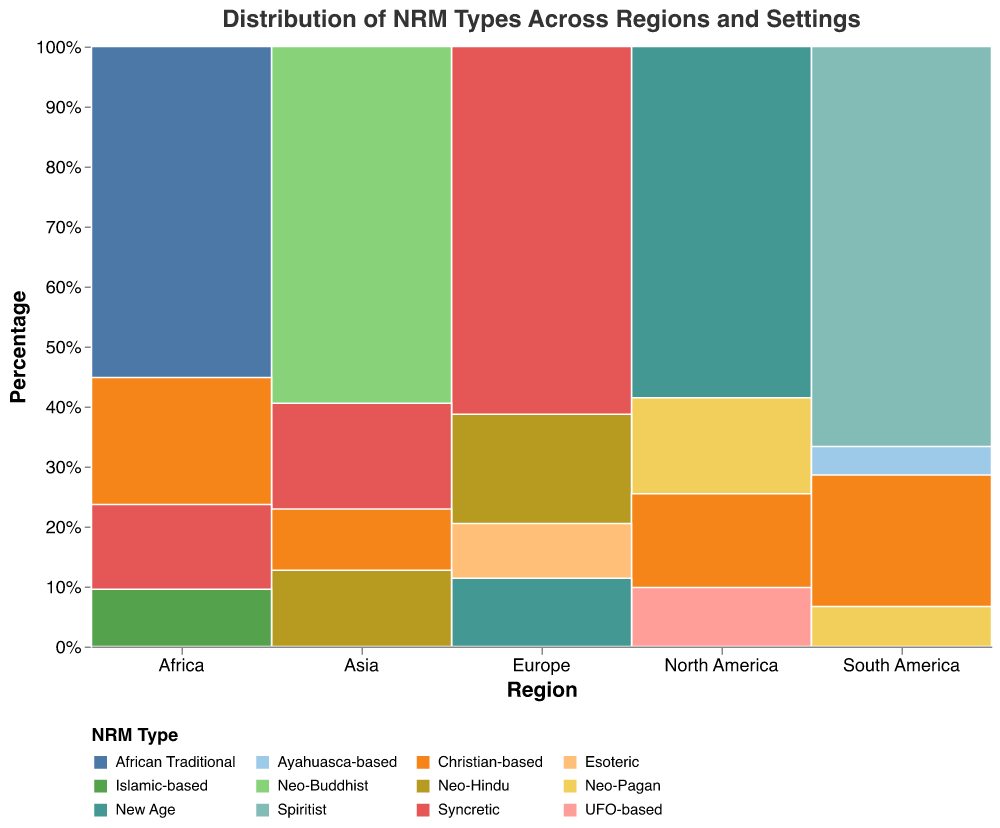What is the title of the figure? The title is located at the top of the figure, centrally aligned and in the largest font size among other text elements. It reads "Distribution of NRM Types Across Regions and Settings."
Answer: Distribution of NRM Types Across Regions and Settings Which region has the highest percentage of Urban NRMs? To determine this, we examine the stacked bars for each region and identify the bars specifically colored for urban settings. By comparing the heights of these sections of the bars, it’s apparent that North America has the highest urban percentage.
Answer: North America What is the smallest NRM type by count in Europe, and where is it located? From the figure, identify the NRM type with the smallest section in the stacked bars for Europe. The rural New Age portion is the smallest.
Answer: Rural New Age Which NRM type in Asia has a higher count, Neo-Buddhist or Syncretic? Look at the stacked bar segments for Neo-Buddhist and Syncretic in Asia. Compare their sizes. The Neo-Buddhist segment is larger than Syncretic.
Answer: Neo-Buddhist What is the percentage of Ayahuasca-based NRMs in South America? Find the bar for South America and identify the Ayahuasca-based segment. The tooltip when hovering over this segment shows the percentage. It’s approximately 20%.
Answer: 20% Compare the count of Christian-based NRMs in North America and Asia. Which region has more? Christian-based in North America and Asia can be identified in their respective bars. North America's Christian-based section is larger.
Answer: North America How do the urban and rural counts of Neo-Hindu NRMs compare in Europe? In the Europe bar, find the segments for urban Neo-Hindu and rural Neo-Hindu. Urban Neo-Hindu is visibly larger.
Answer: Urban is larger What NRM type is most prevalent overall in this mosaic plot? By inspecting the size of segments across all regions, New Age appears to be the most consistently large segment across different regions.
Answer: New Age Are there any NRMs that only appear in urban or rural settings? Scan the figure for NRM types only associated with either urban or rural settings without appearing in both. African Traditional only appears in urban settings and does not appear in rural settings.
Answer: African Traditional Which region has the most diverse variety of NRM types? Evaluate the number of distinct NRM type segments in the bars for each region. Asia and South America show a high diversity, but Asia seems to have more unique NRMs.
Answer: Asia 